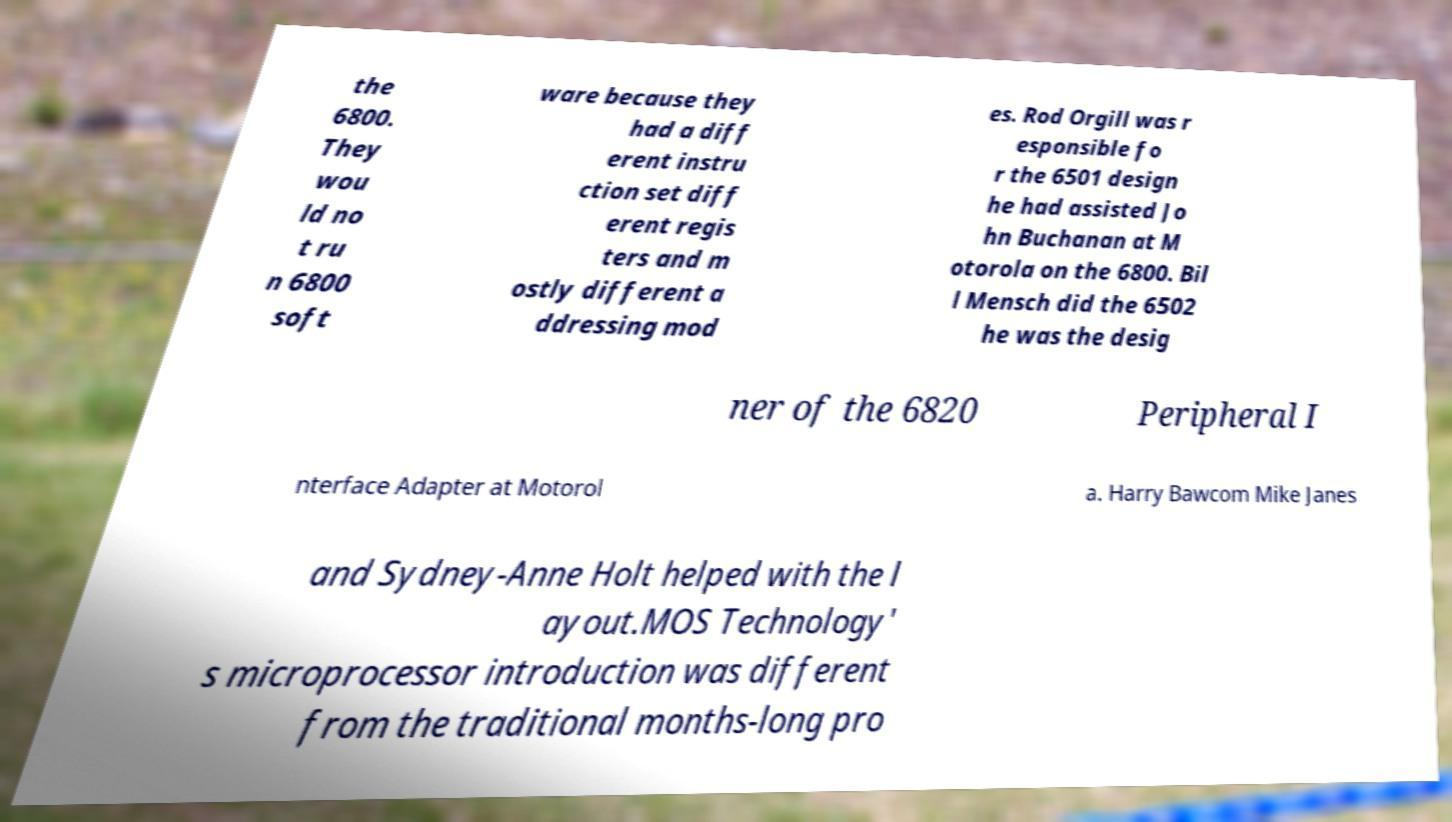Please identify and transcribe the text found in this image. the 6800. They wou ld no t ru n 6800 soft ware because they had a diff erent instru ction set diff erent regis ters and m ostly different a ddressing mod es. Rod Orgill was r esponsible fo r the 6501 design he had assisted Jo hn Buchanan at M otorola on the 6800. Bil l Mensch did the 6502 he was the desig ner of the 6820 Peripheral I nterface Adapter at Motorol a. Harry Bawcom Mike Janes and Sydney-Anne Holt helped with the l ayout.MOS Technology' s microprocessor introduction was different from the traditional months-long pro 